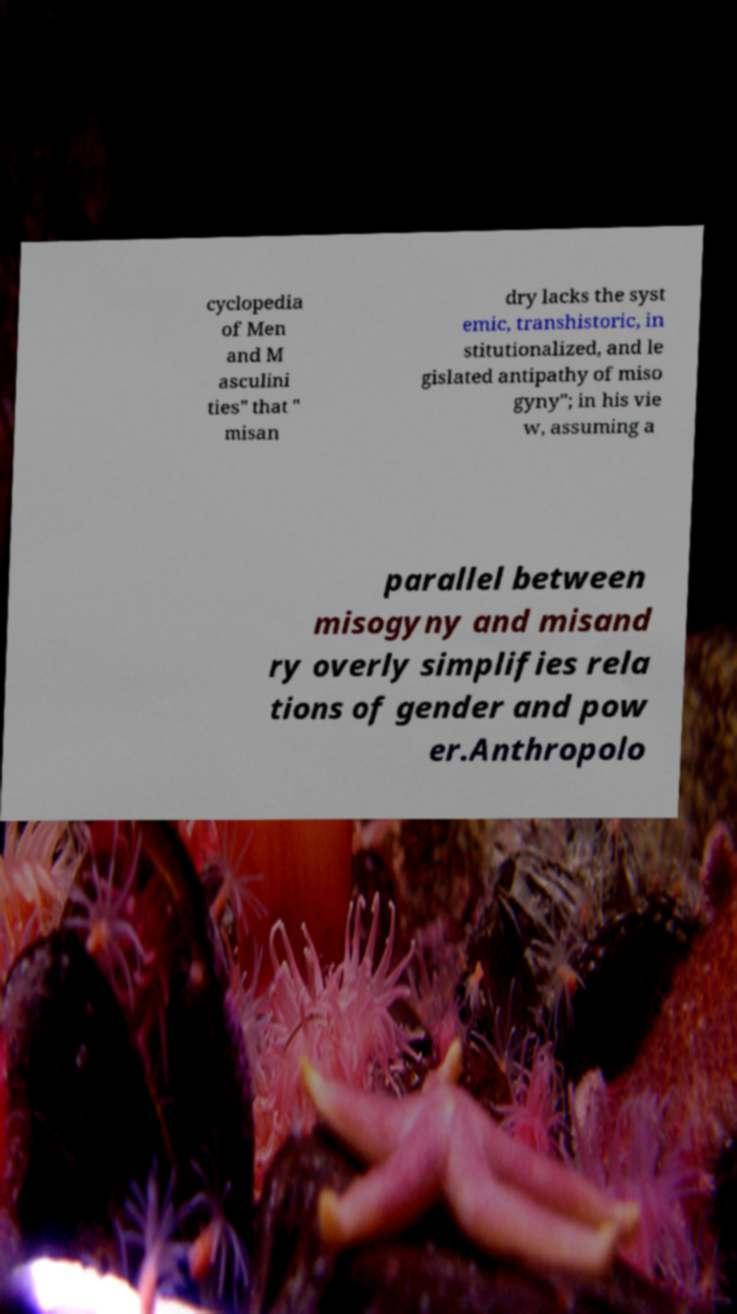What messages or text are displayed in this image? I need them in a readable, typed format. cyclopedia of Men and M asculini ties" that " misan dry lacks the syst emic, transhistoric, in stitutionalized, and le gislated antipathy of miso gyny"; in his vie w, assuming a parallel between misogyny and misand ry overly simplifies rela tions of gender and pow er.Anthropolo 